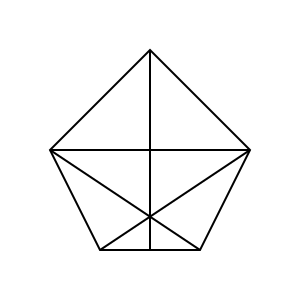Remember our training days with Magda? We used to practice spatial visualization with complex shapes. How many faces does this polyhedron have? Let's approach this step-by-step:

1. First, identify the base shape: It's a pentagon.

2. Count the triangular faces:
   - There are 5 triangular faces formed by connecting the center point to each vertex of the pentagon.
   - There are 5 more triangular faces formed by the lines crossing the pentagon.

3. Count the pentagonal faces:
   - There are 2 pentagonal faces: the top and bottom faces of the polyhedron.

4. Sum up the faces:
   - Triangular faces: $5 + 5 = 10$
   - Pentagonal faces: $2$
   - Total: $10 + 2 = 12$

Therefore, this polyhedron has 12 faces in total.
Answer: 12 faces 